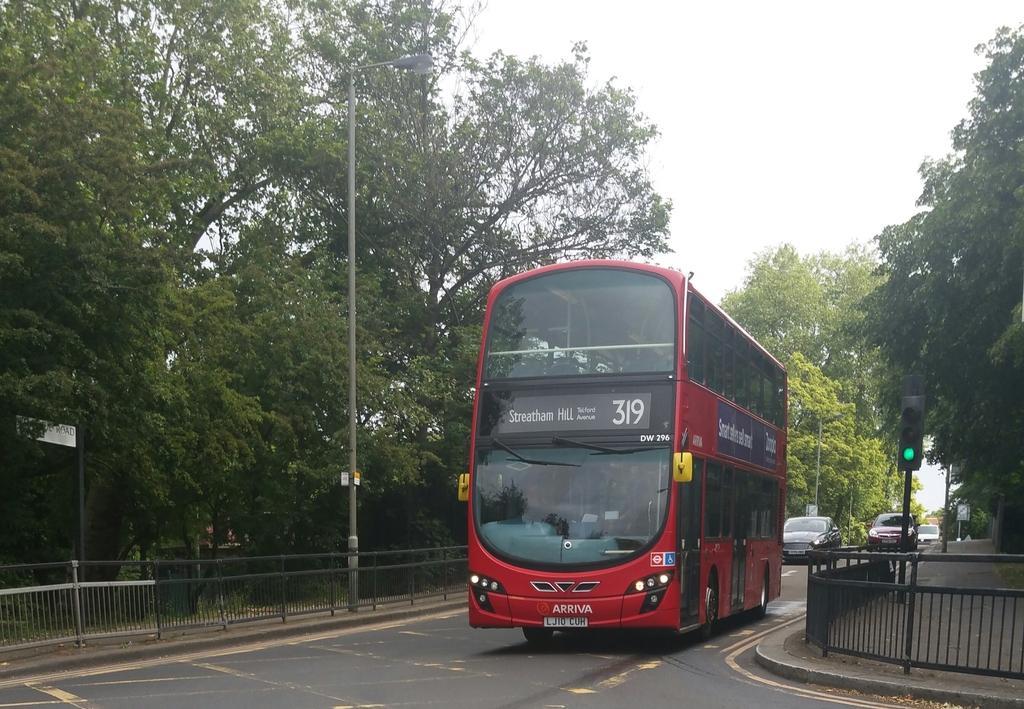Please provide a concise description of this image. In this image I can see the road. To the side of the road I can see the railing, many poles and the trees. In the background I can see the sky. 